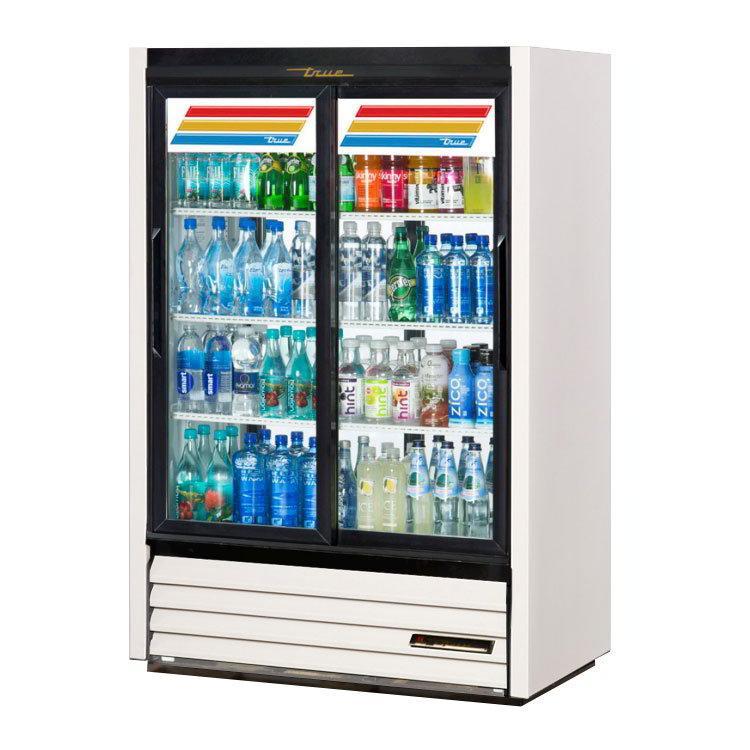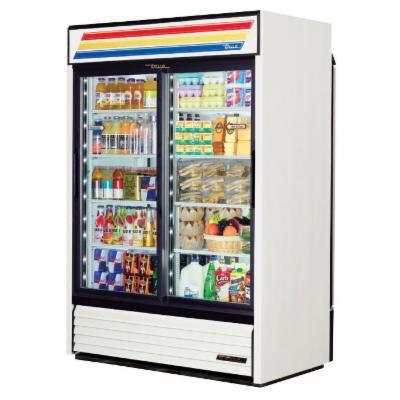The first image is the image on the left, the second image is the image on the right. Considering the images on both sides, is "One image features a vending machine with an undivided band of three colors across the top." valid? Answer yes or no. Yes. The first image is the image on the left, the second image is the image on the right. Assess this claim about the two images: "Two vending machines are white with black trim and two large glass doors, but one has one set of three wide color stripes at the top, while the other has two sets of narrower color stripes.". Correct or not? Answer yes or no. Yes. 